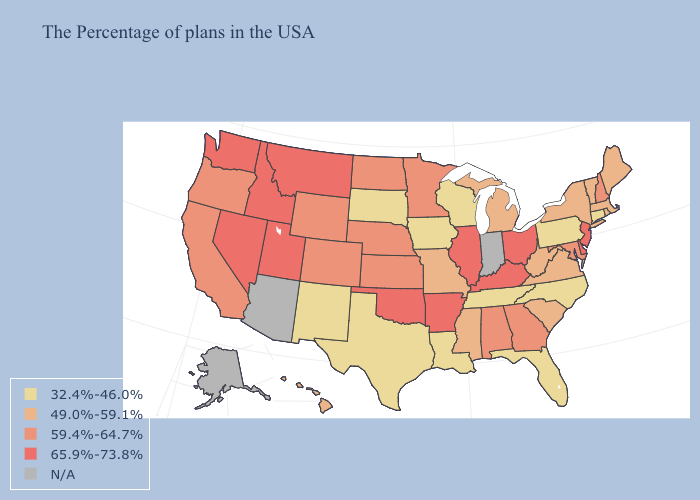Name the states that have a value in the range 65.9%-73.8%?
Short answer required. New Jersey, Delaware, Ohio, Kentucky, Illinois, Arkansas, Oklahoma, Utah, Montana, Idaho, Nevada, Washington. What is the value of Washington?
Quick response, please. 65.9%-73.8%. What is the highest value in the Northeast ?
Write a very short answer. 65.9%-73.8%. Among the states that border Vermont , does New Hampshire have the highest value?
Concise answer only. Yes. What is the value of Pennsylvania?
Quick response, please. 32.4%-46.0%. Does Kentucky have the highest value in the USA?
Quick response, please. Yes. Among the states that border Oklahoma , does Missouri have the highest value?
Keep it brief. No. Name the states that have a value in the range 32.4%-46.0%?
Short answer required. Connecticut, Pennsylvania, North Carolina, Florida, Tennessee, Wisconsin, Louisiana, Iowa, Texas, South Dakota, New Mexico. What is the value of Louisiana?
Give a very brief answer. 32.4%-46.0%. Which states have the lowest value in the USA?
Write a very short answer. Connecticut, Pennsylvania, North Carolina, Florida, Tennessee, Wisconsin, Louisiana, Iowa, Texas, South Dakota, New Mexico. Is the legend a continuous bar?
Be succinct. No. What is the lowest value in the USA?
Answer briefly. 32.4%-46.0%. What is the value of Montana?
Give a very brief answer. 65.9%-73.8%. Which states have the lowest value in the USA?
Answer briefly. Connecticut, Pennsylvania, North Carolina, Florida, Tennessee, Wisconsin, Louisiana, Iowa, Texas, South Dakota, New Mexico. 